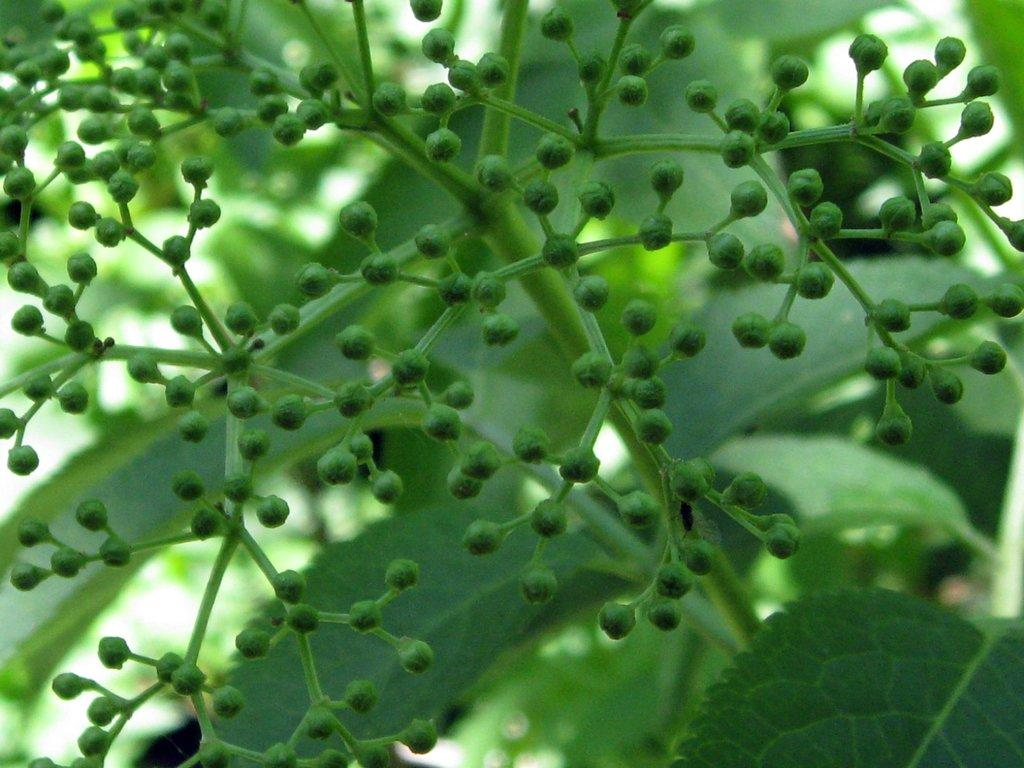What type of plant is in the front of the image? There is a green plant in the front of the image. How would you describe the background of the image? The background of the image is blurred. Can you identify any specific features in the background? Yes, there are leaves visible in the background of the image. What type of magic is being performed by the frogs in the image? There are no frogs present in the image, so no magic can be observed. What time does the clock in the image show? There is no clock present in the image. 